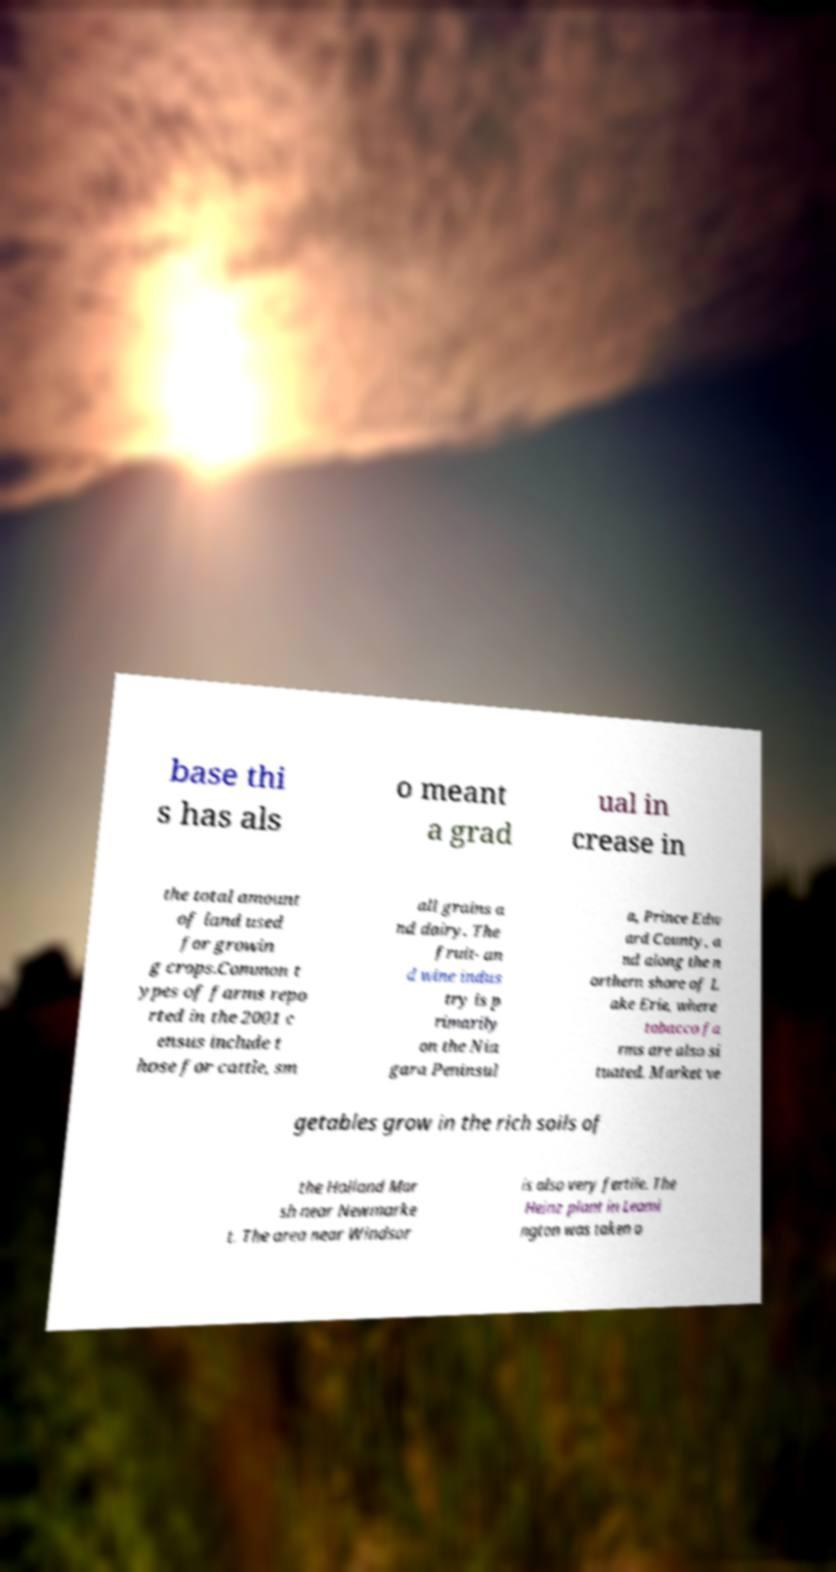What messages or text are displayed in this image? I need them in a readable, typed format. base thi s has als o meant a grad ual in crease in the total amount of land used for growin g crops.Common t ypes of farms repo rted in the 2001 c ensus include t hose for cattle, sm all grains a nd dairy. The fruit- an d wine indus try is p rimarily on the Nia gara Peninsul a, Prince Edw ard County, a nd along the n orthern shore of L ake Erie, where tobacco fa rms are also si tuated. Market ve getables grow in the rich soils of the Holland Mar sh near Newmarke t. The area near Windsor is also very fertile. The Heinz plant in Leami ngton was taken o 